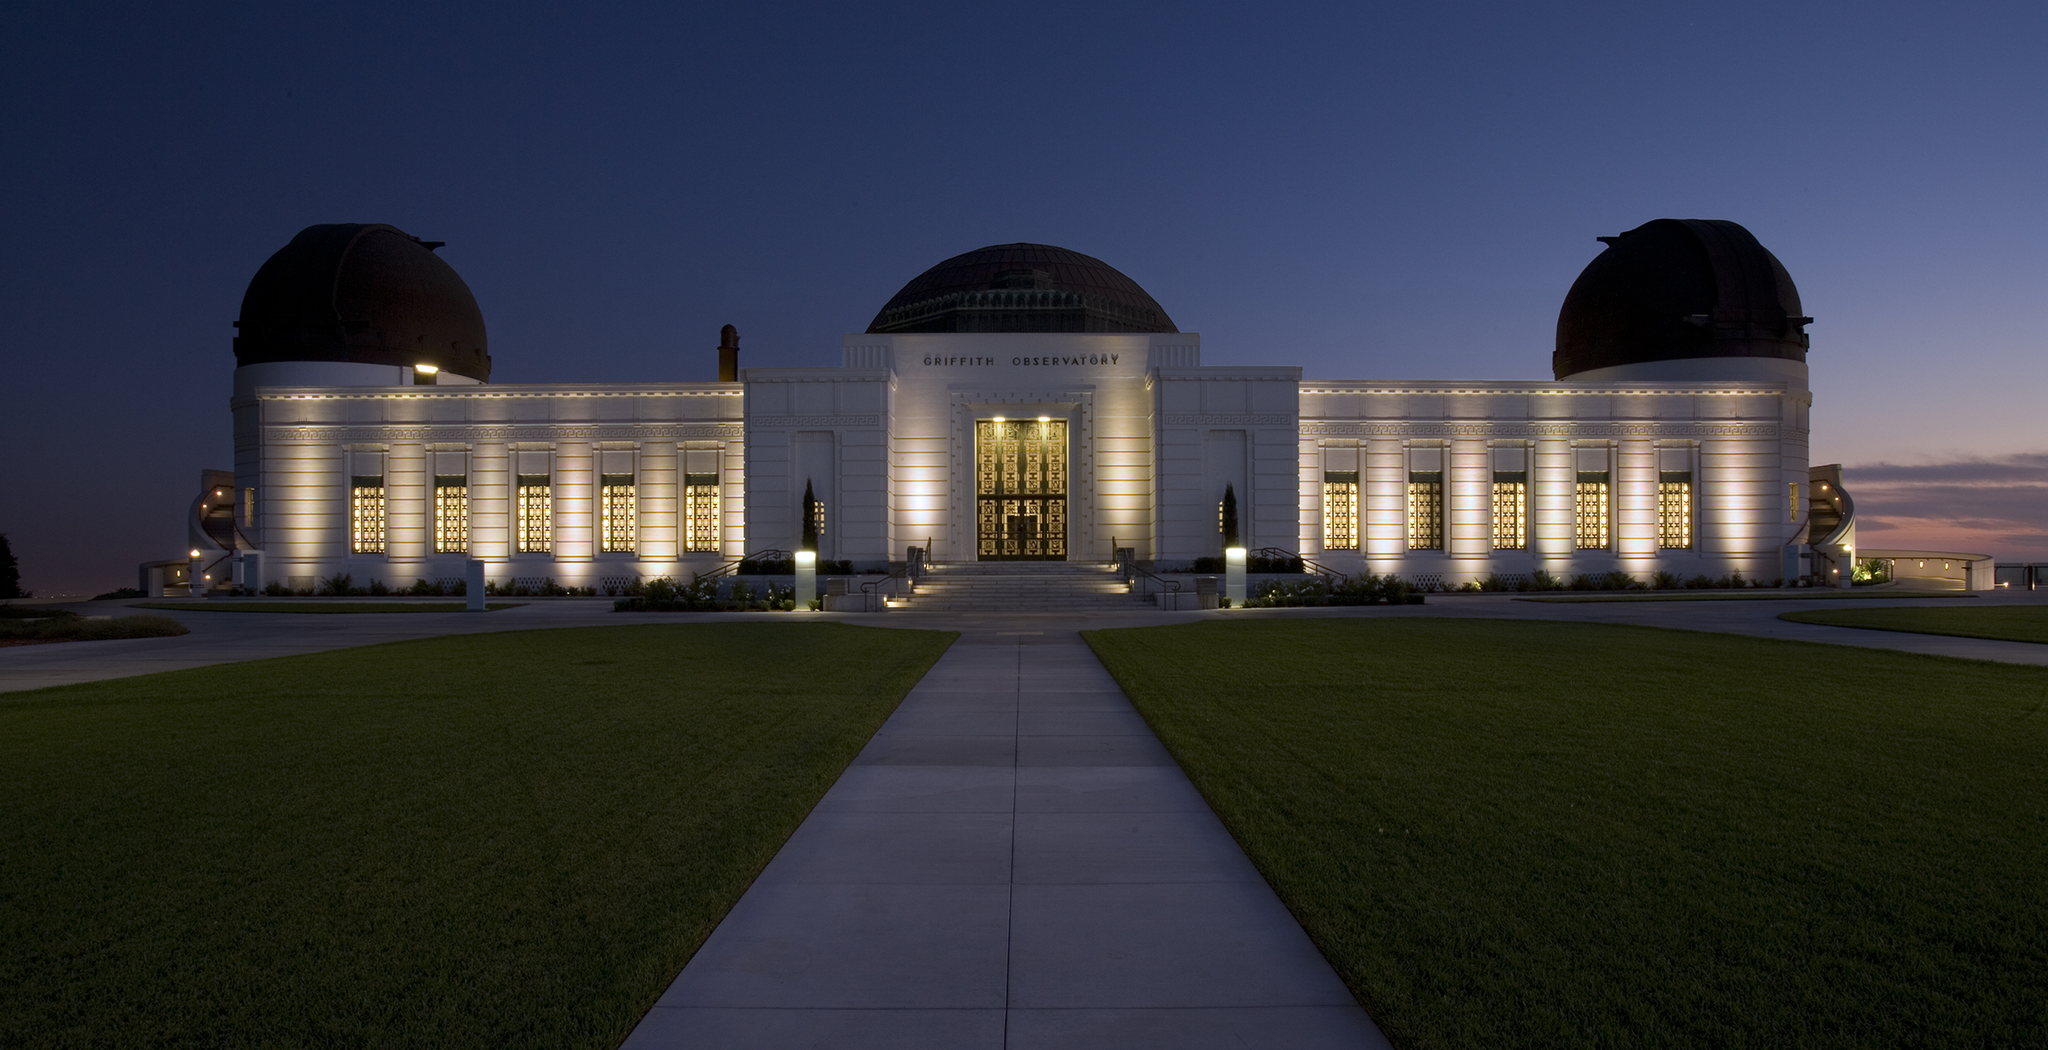Can you describe what you think happens here during the peak hours? During peak hours, the Griffith Observatory bustles with activity and excitement. Visitors from all over converge here, eager to explore and learn. The grand entrance and spacious walkways teem with curious minds, from families with children excitedly pointing out the stars to astronomy enthusiasts discussing celestial phenomena. Tour guides lead groups through interactive exhibits, explaining the intricacies of the universe. Outside, people lay on the green lawn, some stargazing with telescopes while others enjoy the panoramic views of Los Angeles. The observatory serves as a hub of knowledge and wonder, its energy palpable as day turns to night, the sky revealing its starry secrets. 